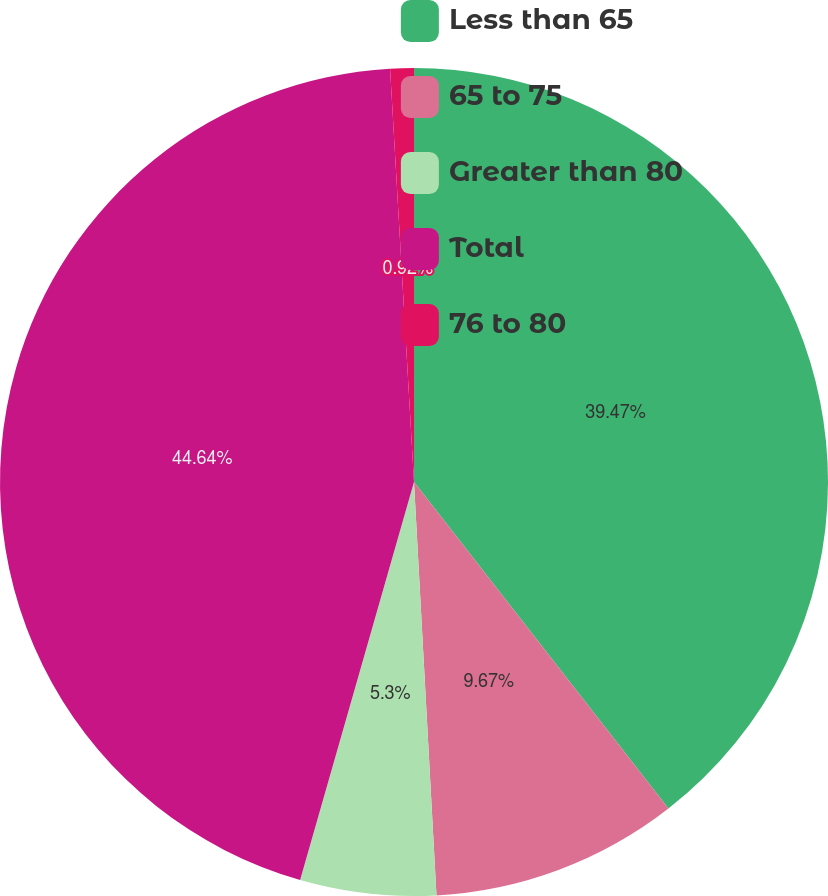Convert chart. <chart><loc_0><loc_0><loc_500><loc_500><pie_chart><fcel>Less than 65<fcel>65 to 75<fcel>Greater than 80<fcel>Total<fcel>76 to 80<nl><fcel>39.47%<fcel>9.67%<fcel>5.3%<fcel>44.65%<fcel>0.92%<nl></chart> 